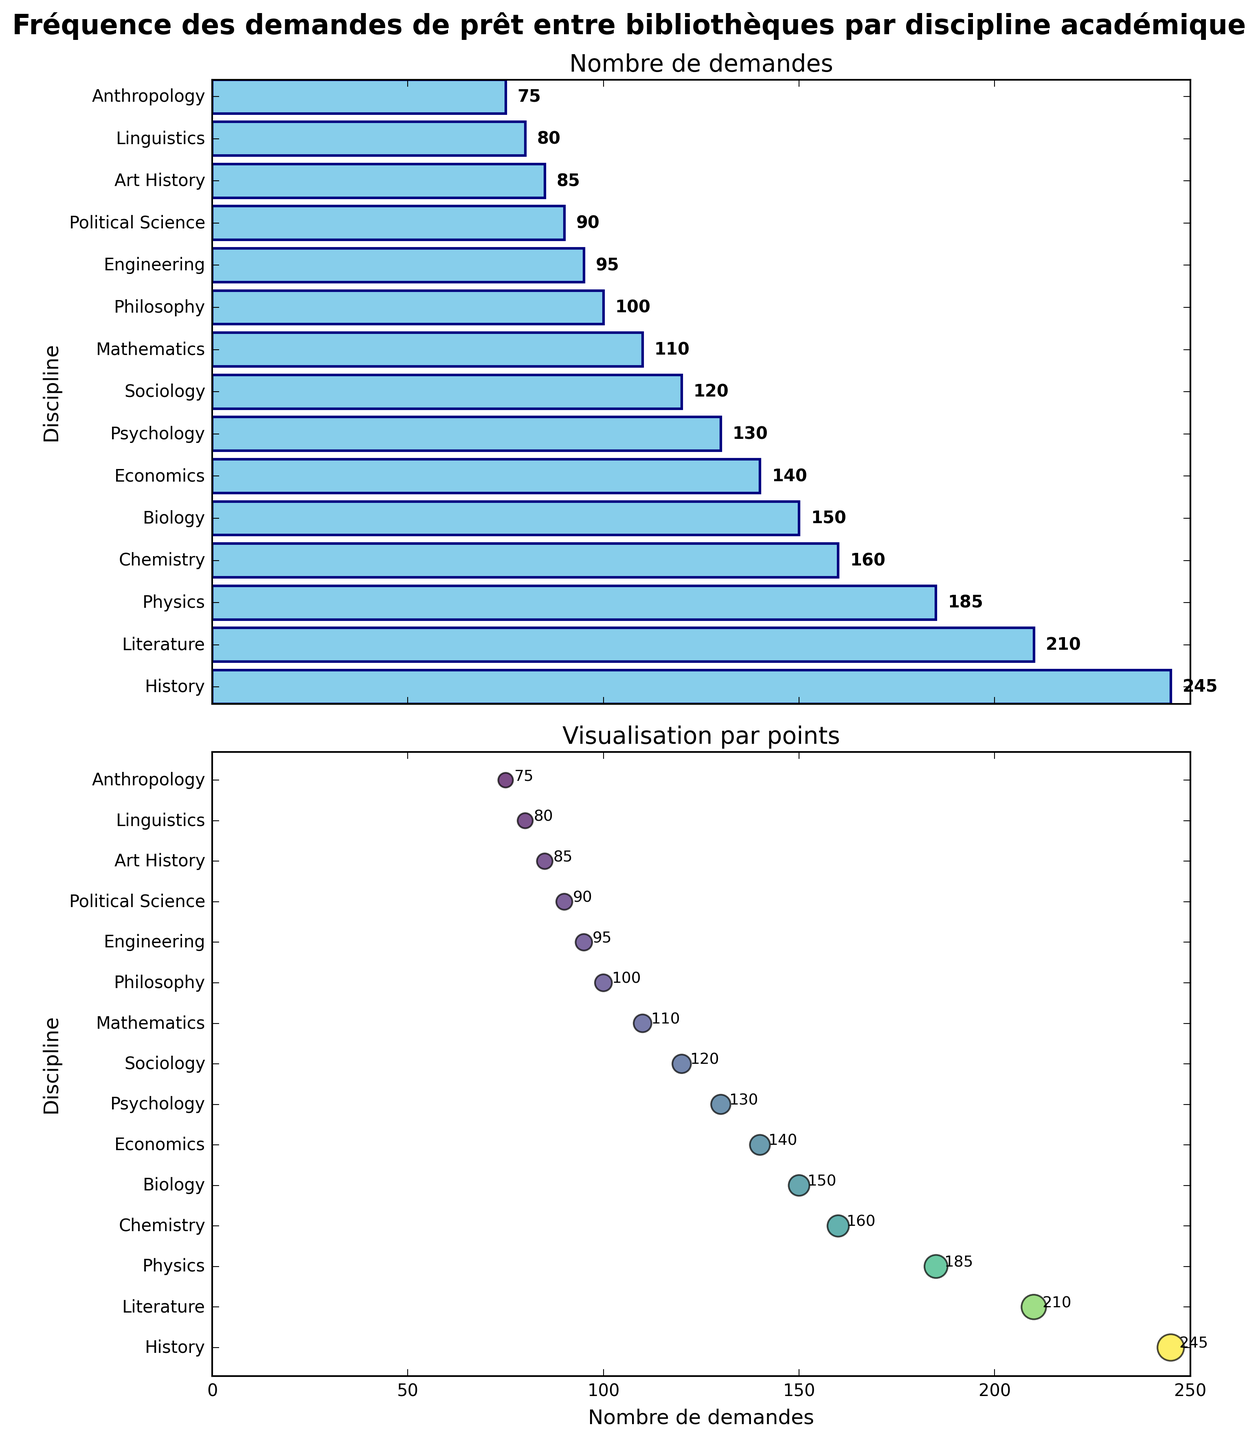Quelle est la discipline avec le plus grand nombre de demandes de prêt interbibliothèque ? On peut observer les barres les plus longues du graphique à barres, la plus longue étant celle pour l'Histoire, indiquant qu'elle a le nombre le plus élevé de demandes.
Answer: Histoire Combien de disciplines ont plus de 100 demandes de prêt interbibliothèque ? En examinant le graphique à barres, on compte les disciplines où les barres dépassent la marque des 100 demandes : Histoire, Littérature, Physique, Chimie, Biologie, Économie, Psychologie, et Sociologie. Ce qui fait un total de 8 disciplines.
Answer: 8 Quel est le nombre total de demandes pour les disciplines de Philosophie et de Mathématiques ? Additionnez les demandes pour Philosophie (100) et Mathématiques (110) : 100 + 110 = 210.
Answer: 210 Quelle est la différence entre les demandes de prêt interbibliothèque pour l'Art Histoire et l'Anthropologie ? La demande pour l'Art Histoire est de 85 et pour l'Anthropologie est de 75. La différence est 85 - 75 = 10.
Answer: 10 Quelle est la couleur principale utilisée dans le graphique à barres ? On peut observer que les barres sont principalement colorées en bleu ciel.
Answer: Bleu ciel Quelle est la discipline avec le moins de demandes de prêt interbibliothèque ? En regardant la barre la plus courte, on trouve qu'Anthropologie a le nombre le plus bas de demandes.
Answer: Anthropologie Quel est le nombre moyen de demandes pour les disciplines d'ingénierie, science politique, art histoire, linguistique et anthropologie ? Additionnez les demandes : 95 (Ingénierie) + 90 (Science Politique) + 85 (Art Histoire) + 80 (Linguistique) + 75 (Anthropologie) = 425. Divisez par 5 : 425 / 5 = 85.
Answer: 85 Comparé à la Biologie, combien de demandes supplémentaires la Histoire a-t-elle reçues ? La demande pour Histoire est de 245 et pour Biologie est de 150, donc 245 - 150 = 95.
Answer: 95 Combien de disciplines ont des demandes comprises entre 90 et 190 ? Les disciplines avec des demandes dans cette plage sont : Physique (185), Chimie (160), Biologie (150), Économie (140), Psychologie (130), Sociologie (120), Mathématiques (110), Philosophie (100), et Science Politique (90), totalisant 9 disciplines.
Answer: 9 